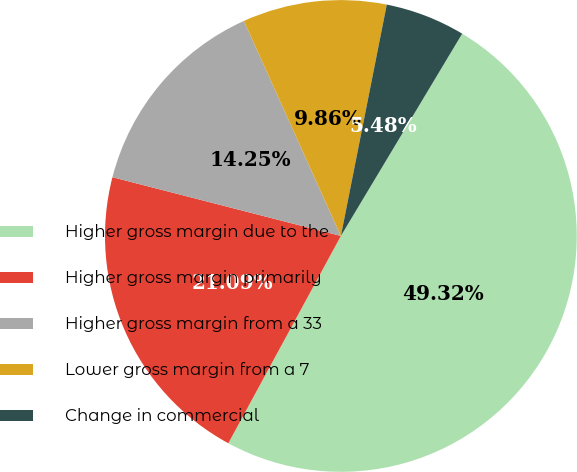<chart> <loc_0><loc_0><loc_500><loc_500><pie_chart><fcel>Higher gross margin due to the<fcel>Higher gross margin primarily<fcel>Higher gross margin from a 33<fcel>Lower gross margin from a 7<fcel>Change in commercial<nl><fcel>49.32%<fcel>21.09%<fcel>14.25%<fcel>9.86%<fcel>5.48%<nl></chart> 